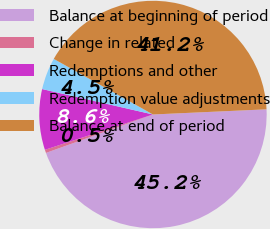Convert chart to OTSL. <chart><loc_0><loc_0><loc_500><loc_500><pie_chart><fcel>Balance at beginning of period<fcel>Change in related<fcel>Redemptions and other<fcel>Redemption value adjustments<fcel>Balance at end of period<nl><fcel>45.23%<fcel>0.46%<fcel>8.62%<fcel>4.54%<fcel>41.15%<nl></chart> 